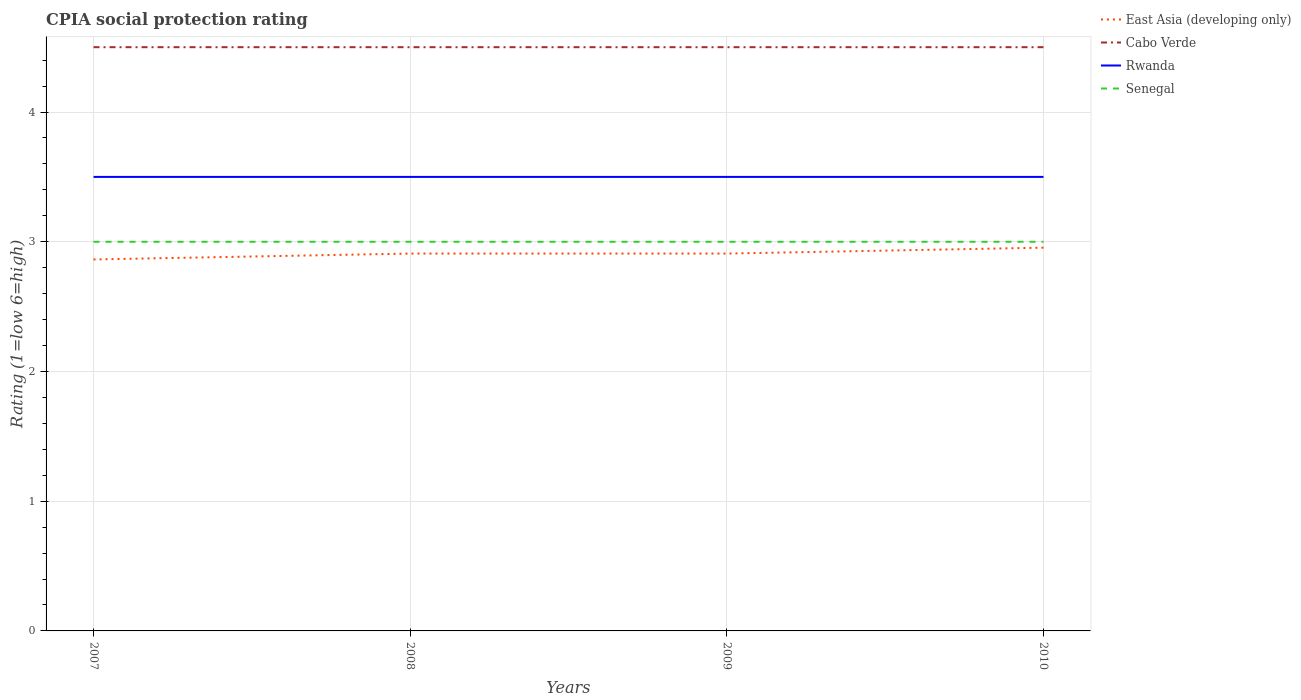How many different coloured lines are there?
Provide a short and direct response. 4. Does the line corresponding to Cabo Verde intersect with the line corresponding to Senegal?
Provide a short and direct response. No. Across all years, what is the maximum CPIA rating in East Asia (developing only)?
Provide a short and direct response. 2.86. In which year was the CPIA rating in Rwanda maximum?
Make the answer very short. 2007. What is the total CPIA rating in East Asia (developing only) in the graph?
Keep it short and to the point. -0.05. What is the difference between the highest and the second highest CPIA rating in Rwanda?
Make the answer very short. 0. Is the CPIA rating in Rwanda strictly greater than the CPIA rating in Cabo Verde over the years?
Your answer should be compact. Yes. How many lines are there?
Offer a very short reply. 4. What is the difference between two consecutive major ticks on the Y-axis?
Make the answer very short. 1. What is the title of the graph?
Make the answer very short. CPIA social protection rating. What is the label or title of the X-axis?
Your answer should be very brief. Years. What is the label or title of the Y-axis?
Provide a short and direct response. Rating (1=low 6=high). What is the Rating (1=low 6=high) of East Asia (developing only) in 2007?
Offer a terse response. 2.86. What is the Rating (1=low 6=high) of Rwanda in 2007?
Ensure brevity in your answer.  3.5. What is the Rating (1=low 6=high) in East Asia (developing only) in 2008?
Provide a short and direct response. 2.91. What is the Rating (1=low 6=high) in Rwanda in 2008?
Provide a succinct answer. 3.5. What is the Rating (1=low 6=high) of East Asia (developing only) in 2009?
Provide a succinct answer. 2.91. What is the Rating (1=low 6=high) of Cabo Verde in 2009?
Your answer should be very brief. 4.5. What is the Rating (1=low 6=high) of East Asia (developing only) in 2010?
Offer a terse response. 2.95. What is the Rating (1=low 6=high) in Cabo Verde in 2010?
Your response must be concise. 4.5. What is the Rating (1=low 6=high) of Senegal in 2010?
Provide a short and direct response. 3. Across all years, what is the maximum Rating (1=low 6=high) in East Asia (developing only)?
Offer a very short reply. 2.95. Across all years, what is the maximum Rating (1=low 6=high) of Cabo Verde?
Your response must be concise. 4.5. Across all years, what is the maximum Rating (1=low 6=high) in Rwanda?
Provide a succinct answer. 3.5. Across all years, what is the maximum Rating (1=low 6=high) in Senegal?
Provide a short and direct response. 3. Across all years, what is the minimum Rating (1=low 6=high) in East Asia (developing only)?
Ensure brevity in your answer.  2.86. Across all years, what is the minimum Rating (1=low 6=high) in Cabo Verde?
Offer a terse response. 4.5. Across all years, what is the minimum Rating (1=low 6=high) in Senegal?
Provide a short and direct response. 3. What is the total Rating (1=low 6=high) of East Asia (developing only) in the graph?
Provide a succinct answer. 11.64. What is the total Rating (1=low 6=high) in Rwanda in the graph?
Ensure brevity in your answer.  14. What is the total Rating (1=low 6=high) in Senegal in the graph?
Your answer should be very brief. 12. What is the difference between the Rating (1=low 6=high) of East Asia (developing only) in 2007 and that in 2008?
Offer a terse response. -0.05. What is the difference between the Rating (1=low 6=high) of Rwanda in 2007 and that in 2008?
Your answer should be compact. 0. What is the difference between the Rating (1=low 6=high) of East Asia (developing only) in 2007 and that in 2009?
Provide a short and direct response. -0.05. What is the difference between the Rating (1=low 6=high) of Rwanda in 2007 and that in 2009?
Ensure brevity in your answer.  0. What is the difference between the Rating (1=low 6=high) in Senegal in 2007 and that in 2009?
Give a very brief answer. 0. What is the difference between the Rating (1=low 6=high) in East Asia (developing only) in 2007 and that in 2010?
Provide a succinct answer. -0.09. What is the difference between the Rating (1=low 6=high) of Cabo Verde in 2007 and that in 2010?
Give a very brief answer. 0. What is the difference between the Rating (1=low 6=high) of East Asia (developing only) in 2008 and that in 2009?
Your response must be concise. 0. What is the difference between the Rating (1=low 6=high) of Cabo Verde in 2008 and that in 2009?
Ensure brevity in your answer.  0. What is the difference between the Rating (1=low 6=high) of Rwanda in 2008 and that in 2009?
Provide a short and direct response. 0. What is the difference between the Rating (1=low 6=high) in East Asia (developing only) in 2008 and that in 2010?
Your response must be concise. -0.05. What is the difference between the Rating (1=low 6=high) of Cabo Verde in 2008 and that in 2010?
Your response must be concise. 0. What is the difference between the Rating (1=low 6=high) of East Asia (developing only) in 2009 and that in 2010?
Your response must be concise. -0.05. What is the difference between the Rating (1=low 6=high) in Senegal in 2009 and that in 2010?
Make the answer very short. 0. What is the difference between the Rating (1=low 6=high) of East Asia (developing only) in 2007 and the Rating (1=low 6=high) of Cabo Verde in 2008?
Keep it short and to the point. -1.64. What is the difference between the Rating (1=low 6=high) in East Asia (developing only) in 2007 and the Rating (1=low 6=high) in Rwanda in 2008?
Ensure brevity in your answer.  -0.64. What is the difference between the Rating (1=low 6=high) in East Asia (developing only) in 2007 and the Rating (1=low 6=high) in Senegal in 2008?
Ensure brevity in your answer.  -0.14. What is the difference between the Rating (1=low 6=high) of Cabo Verde in 2007 and the Rating (1=low 6=high) of Rwanda in 2008?
Keep it short and to the point. 1. What is the difference between the Rating (1=low 6=high) in Cabo Verde in 2007 and the Rating (1=low 6=high) in Senegal in 2008?
Make the answer very short. 1.5. What is the difference between the Rating (1=low 6=high) in East Asia (developing only) in 2007 and the Rating (1=low 6=high) in Cabo Verde in 2009?
Make the answer very short. -1.64. What is the difference between the Rating (1=low 6=high) in East Asia (developing only) in 2007 and the Rating (1=low 6=high) in Rwanda in 2009?
Your response must be concise. -0.64. What is the difference between the Rating (1=low 6=high) in East Asia (developing only) in 2007 and the Rating (1=low 6=high) in Senegal in 2009?
Your response must be concise. -0.14. What is the difference between the Rating (1=low 6=high) in Cabo Verde in 2007 and the Rating (1=low 6=high) in Rwanda in 2009?
Give a very brief answer. 1. What is the difference between the Rating (1=low 6=high) in Cabo Verde in 2007 and the Rating (1=low 6=high) in Senegal in 2009?
Give a very brief answer. 1.5. What is the difference between the Rating (1=low 6=high) of Rwanda in 2007 and the Rating (1=low 6=high) of Senegal in 2009?
Ensure brevity in your answer.  0.5. What is the difference between the Rating (1=low 6=high) in East Asia (developing only) in 2007 and the Rating (1=low 6=high) in Cabo Verde in 2010?
Offer a terse response. -1.64. What is the difference between the Rating (1=low 6=high) of East Asia (developing only) in 2007 and the Rating (1=low 6=high) of Rwanda in 2010?
Give a very brief answer. -0.64. What is the difference between the Rating (1=low 6=high) of East Asia (developing only) in 2007 and the Rating (1=low 6=high) of Senegal in 2010?
Your answer should be compact. -0.14. What is the difference between the Rating (1=low 6=high) of Rwanda in 2007 and the Rating (1=low 6=high) of Senegal in 2010?
Make the answer very short. 0.5. What is the difference between the Rating (1=low 6=high) of East Asia (developing only) in 2008 and the Rating (1=low 6=high) of Cabo Verde in 2009?
Ensure brevity in your answer.  -1.59. What is the difference between the Rating (1=low 6=high) of East Asia (developing only) in 2008 and the Rating (1=low 6=high) of Rwanda in 2009?
Offer a terse response. -0.59. What is the difference between the Rating (1=low 6=high) of East Asia (developing only) in 2008 and the Rating (1=low 6=high) of Senegal in 2009?
Provide a short and direct response. -0.09. What is the difference between the Rating (1=low 6=high) of Cabo Verde in 2008 and the Rating (1=low 6=high) of Rwanda in 2009?
Your answer should be compact. 1. What is the difference between the Rating (1=low 6=high) in Cabo Verde in 2008 and the Rating (1=low 6=high) in Senegal in 2009?
Keep it short and to the point. 1.5. What is the difference between the Rating (1=low 6=high) of Rwanda in 2008 and the Rating (1=low 6=high) of Senegal in 2009?
Ensure brevity in your answer.  0.5. What is the difference between the Rating (1=low 6=high) in East Asia (developing only) in 2008 and the Rating (1=low 6=high) in Cabo Verde in 2010?
Offer a terse response. -1.59. What is the difference between the Rating (1=low 6=high) of East Asia (developing only) in 2008 and the Rating (1=low 6=high) of Rwanda in 2010?
Provide a succinct answer. -0.59. What is the difference between the Rating (1=low 6=high) of East Asia (developing only) in 2008 and the Rating (1=low 6=high) of Senegal in 2010?
Make the answer very short. -0.09. What is the difference between the Rating (1=low 6=high) of Cabo Verde in 2008 and the Rating (1=low 6=high) of Rwanda in 2010?
Keep it short and to the point. 1. What is the difference between the Rating (1=low 6=high) in East Asia (developing only) in 2009 and the Rating (1=low 6=high) in Cabo Verde in 2010?
Provide a succinct answer. -1.59. What is the difference between the Rating (1=low 6=high) in East Asia (developing only) in 2009 and the Rating (1=low 6=high) in Rwanda in 2010?
Offer a very short reply. -0.59. What is the difference between the Rating (1=low 6=high) in East Asia (developing only) in 2009 and the Rating (1=low 6=high) in Senegal in 2010?
Offer a terse response. -0.09. What is the difference between the Rating (1=low 6=high) of Cabo Verde in 2009 and the Rating (1=low 6=high) of Senegal in 2010?
Ensure brevity in your answer.  1.5. What is the difference between the Rating (1=low 6=high) in Rwanda in 2009 and the Rating (1=low 6=high) in Senegal in 2010?
Your answer should be very brief. 0.5. What is the average Rating (1=low 6=high) in East Asia (developing only) per year?
Your response must be concise. 2.91. What is the average Rating (1=low 6=high) of Rwanda per year?
Your answer should be very brief. 3.5. In the year 2007, what is the difference between the Rating (1=low 6=high) of East Asia (developing only) and Rating (1=low 6=high) of Cabo Verde?
Give a very brief answer. -1.64. In the year 2007, what is the difference between the Rating (1=low 6=high) of East Asia (developing only) and Rating (1=low 6=high) of Rwanda?
Make the answer very short. -0.64. In the year 2007, what is the difference between the Rating (1=low 6=high) of East Asia (developing only) and Rating (1=low 6=high) of Senegal?
Provide a short and direct response. -0.14. In the year 2007, what is the difference between the Rating (1=low 6=high) of Cabo Verde and Rating (1=low 6=high) of Senegal?
Your answer should be compact. 1.5. In the year 2007, what is the difference between the Rating (1=low 6=high) in Rwanda and Rating (1=low 6=high) in Senegal?
Ensure brevity in your answer.  0.5. In the year 2008, what is the difference between the Rating (1=low 6=high) of East Asia (developing only) and Rating (1=low 6=high) of Cabo Verde?
Ensure brevity in your answer.  -1.59. In the year 2008, what is the difference between the Rating (1=low 6=high) in East Asia (developing only) and Rating (1=low 6=high) in Rwanda?
Your answer should be very brief. -0.59. In the year 2008, what is the difference between the Rating (1=low 6=high) in East Asia (developing only) and Rating (1=low 6=high) in Senegal?
Give a very brief answer. -0.09. In the year 2008, what is the difference between the Rating (1=low 6=high) of Cabo Verde and Rating (1=low 6=high) of Rwanda?
Offer a terse response. 1. In the year 2009, what is the difference between the Rating (1=low 6=high) in East Asia (developing only) and Rating (1=low 6=high) in Cabo Verde?
Your answer should be compact. -1.59. In the year 2009, what is the difference between the Rating (1=low 6=high) in East Asia (developing only) and Rating (1=low 6=high) in Rwanda?
Provide a short and direct response. -0.59. In the year 2009, what is the difference between the Rating (1=low 6=high) in East Asia (developing only) and Rating (1=low 6=high) in Senegal?
Provide a short and direct response. -0.09. In the year 2009, what is the difference between the Rating (1=low 6=high) in Cabo Verde and Rating (1=low 6=high) in Senegal?
Offer a terse response. 1.5. In the year 2009, what is the difference between the Rating (1=low 6=high) of Rwanda and Rating (1=low 6=high) of Senegal?
Provide a short and direct response. 0.5. In the year 2010, what is the difference between the Rating (1=low 6=high) in East Asia (developing only) and Rating (1=low 6=high) in Cabo Verde?
Your response must be concise. -1.55. In the year 2010, what is the difference between the Rating (1=low 6=high) in East Asia (developing only) and Rating (1=low 6=high) in Rwanda?
Your response must be concise. -0.55. In the year 2010, what is the difference between the Rating (1=low 6=high) of East Asia (developing only) and Rating (1=low 6=high) of Senegal?
Your answer should be compact. -0.05. What is the ratio of the Rating (1=low 6=high) in East Asia (developing only) in 2007 to that in 2008?
Your answer should be very brief. 0.98. What is the ratio of the Rating (1=low 6=high) in East Asia (developing only) in 2007 to that in 2009?
Give a very brief answer. 0.98. What is the ratio of the Rating (1=low 6=high) in Cabo Verde in 2007 to that in 2009?
Keep it short and to the point. 1. What is the ratio of the Rating (1=low 6=high) of Rwanda in 2007 to that in 2009?
Keep it short and to the point. 1. What is the ratio of the Rating (1=low 6=high) in Senegal in 2007 to that in 2009?
Your response must be concise. 1. What is the ratio of the Rating (1=low 6=high) in East Asia (developing only) in 2007 to that in 2010?
Provide a succinct answer. 0.97. What is the ratio of the Rating (1=low 6=high) in Senegal in 2007 to that in 2010?
Provide a succinct answer. 1. What is the ratio of the Rating (1=low 6=high) in Senegal in 2008 to that in 2009?
Your response must be concise. 1. What is the ratio of the Rating (1=low 6=high) in East Asia (developing only) in 2008 to that in 2010?
Your response must be concise. 0.98. What is the ratio of the Rating (1=low 6=high) of Cabo Verde in 2008 to that in 2010?
Your response must be concise. 1. What is the ratio of the Rating (1=low 6=high) in Rwanda in 2008 to that in 2010?
Give a very brief answer. 1. What is the ratio of the Rating (1=low 6=high) of East Asia (developing only) in 2009 to that in 2010?
Your answer should be compact. 0.98. What is the ratio of the Rating (1=low 6=high) in Cabo Verde in 2009 to that in 2010?
Provide a succinct answer. 1. What is the ratio of the Rating (1=low 6=high) in Senegal in 2009 to that in 2010?
Provide a short and direct response. 1. What is the difference between the highest and the second highest Rating (1=low 6=high) of East Asia (developing only)?
Your response must be concise. 0.05. What is the difference between the highest and the second highest Rating (1=low 6=high) of Senegal?
Your response must be concise. 0. What is the difference between the highest and the lowest Rating (1=low 6=high) of East Asia (developing only)?
Your answer should be very brief. 0.09. What is the difference between the highest and the lowest Rating (1=low 6=high) in Cabo Verde?
Make the answer very short. 0. What is the difference between the highest and the lowest Rating (1=low 6=high) of Rwanda?
Offer a very short reply. 0. What is the difference between the highest and the lowest Rating (1=low 6=high) of Senegal?
Your answer should be compact. 0. 